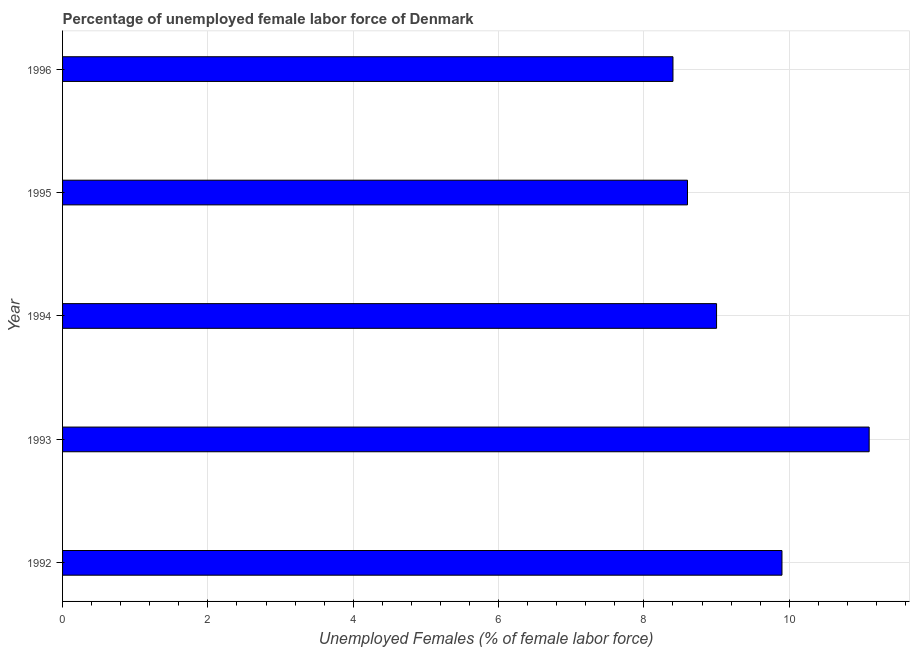Does the graph contain any zero values?
Provide a succinct answer. No. What is the title of the graph?
Offer a terse response. Percentage of unemployed female labor force of Denmark. What is the label or title of the X-axis?
Make the answer very short. Unemployed Females (% of female labor force). What is the total unemployed female labour force in 1993?
Your answer should be very brief. 11.1. Across all years, what is the maximum total unemployed female labour force?
Give a very brief answer. 11.1. Across all years, what is the minimum total unemployed female labour force?
Provide a succinct answer. 8.4. What is the sum of the total unemployed female labour force?
Make the answer very short. 47. What is the difference between the total unemployed female labour force in 1992 and 1996?
Provide a succinct answer. 1.5. What is the average total unemployed female labour force per year?
Offer a very short reply. 9.4. What is the median total unemployed female labour force?
Your response must be concise. 9. What is the ratio of the total unemployed female labour force in 1992 to that in 1993?
Ensure brevity in your answer.  0.89. Is the total unemployed female labour force in 1992 less than that in 1994?
Offer a very short reply. No. In how many years, is the total unemployed female labour force greater than the average total unemployed female labour force taken over all years?
Your answer should be very brief. 2. How many bars are there?
Give a very brief answer. 5. How many years are there in the graph?
Your answer should be very brief. 5. What is the difference between two consecutive major ticks on the X-axis?
Your answer should be compact. 2. What is the Unemployed Females (% of female labor force) in 1992?
Keep it short and to the point. 9.9. What is the Unemployed Females (% of female labor force) in 1993?
Make the answer very short. 11.1. What is the Unemployed Females (% of female labor force) of 1995?
Offer a terse response. 8.6. What is the Unemployed Females (% of female labor force) of 1996?
Offer a terse response. 8.4. What is the difference between the Unemployed Females (% of female labor force) in 1992 and 1994?
Offer a terse response. 0.9. What is the difference between the Unemployed Females (% of female labor force) in 1992 and 1995?
Offer a terse response. 1.3. What is the difference between the Unemployed Females (% of female labor force) in 1993 and 1995?
Give a very brief answer. 2.5. What is the difference between the Unemployed Females (% of female labor force) in 1993 and 1996?
Offer a very short reply. 2.7. What is the difference between the Unemployed Females (% of female labor force) in 1994 and 1995?
Your answer should be compact. 0.4. What is the difference between the Unemployed Females (% of female labor force) in 1994 and 1996?
Provide a short and direct response. 0.6. What is the difference between the Unemployed Females (% of female labor force) in 1995 and 1996?
Your answer should be very brief. 0.2. What is the ratio of the Unemployed Females (% of female labor force) in 1992 to that in 1993?
Make the answer very short. 0.89. What is the ratio of the Unemployed Females (% of female labor force) in 1992 to that in 1994?
Offer a terse response. 1.1. What is the ratio of the Unemployed Females (% of female labor force) in 1992 to that in 1995?
Provide a short and direct response. 1.15. What is the ratio of the Unemployed Females (% of female labor force) in 1992 to that in 1996?
Provide a short and direct response. 1.18. What is the ratio of the Unemployed Females (% of female labor force) in 1993 to that in 1994?
Offer a very short reply. 1.23. What is the ratio of the Unemployed Females (% of female labor force) in 1993 to that in 1995?
Provide a succinct answer. 1.29. What is the ratio of the Unemployed Females (% of female labor force) in 1993 to that in 1996?
Offer a terse response. 1.32. What is the ratio of the Unemployed Females (% of female labor force) in 1994 to that in 1995?
Provide a succinct answer. 1.05. What is the ratio of the Unemployed Females (% of female labor force) in 1994 to that in 1996?
Your answer should be very brief. 1.07. What is the ratio of the Unemployed Females (% of female labor force) in 1995 to that in 1996?
Provide a short and direct response. 1.02. 